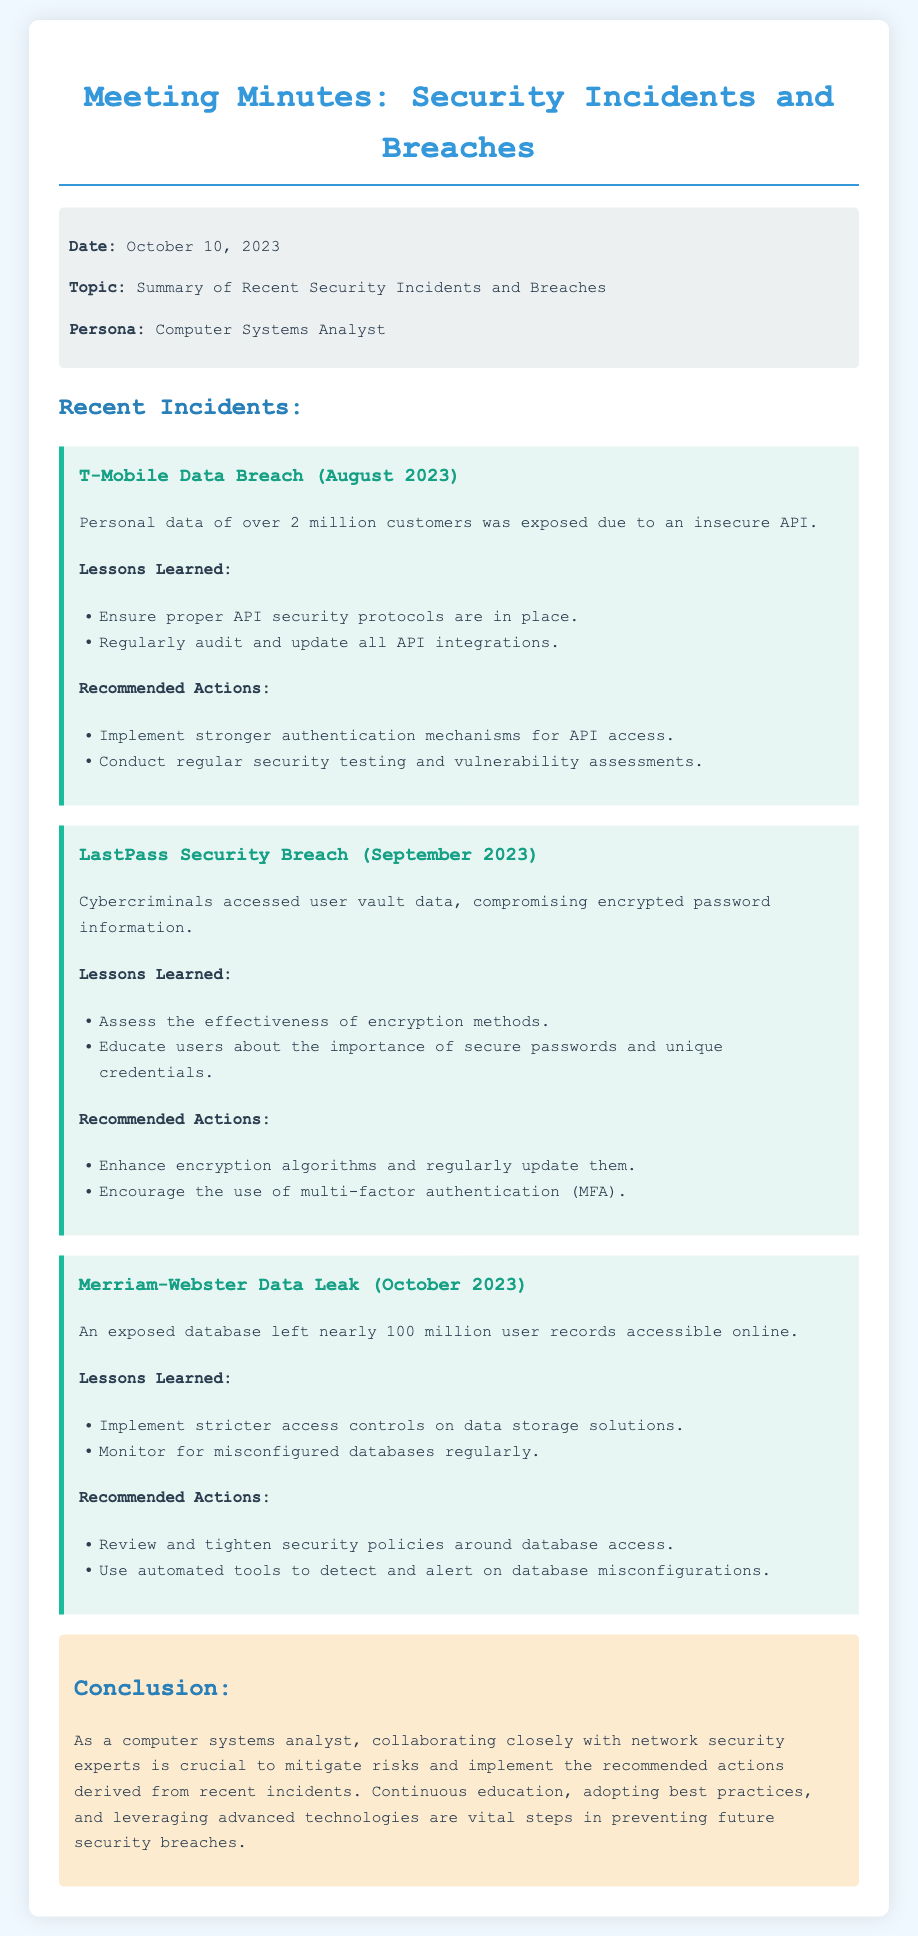What incident occurred in August 2023? The document mentions the T-Mobile Data Breach occurring in August 2023.
Answer: T-Mobile Data Breach How many customer records were exposed in the T-Mobile incident? The document states that over 2 million customers were impacted.
Answer: 2 million What was the main cause of the LastPass security breach? The cause was the compromise of encrypted password information accessed by cybercriminals.
Answer: Compromising encrypted password information What is one recommended action for securing APIs? The document advises implementing stronger authentication mechanisms for API access.
Answer: Stronger authentication mechanisms What date was the Merriam-Webster data leak incident reported? The data leak is noted to have occurred in October 2023.
Answer: October 2023 What lesson was learned from the Merriam-Webster incident regarding data storage? The lesson indicated the need for stricter access controls on data storage solutions.
Answer: Stricter access controls What is a suggested action for enhancing user security post-LastPass breach? The document suggests encouraging the use of multi-factor authentication.
Answer: Multi-factor authentication Which organization had a data breach in September 2023? The document specifies LastPass as the organization involved in the September 2023 incident.
Answer: LastPass What was the purpose of this meeting document? The purpose was to summarize recent security incidents and breaches.
Answer: Summary of recent security incidents and breaches 